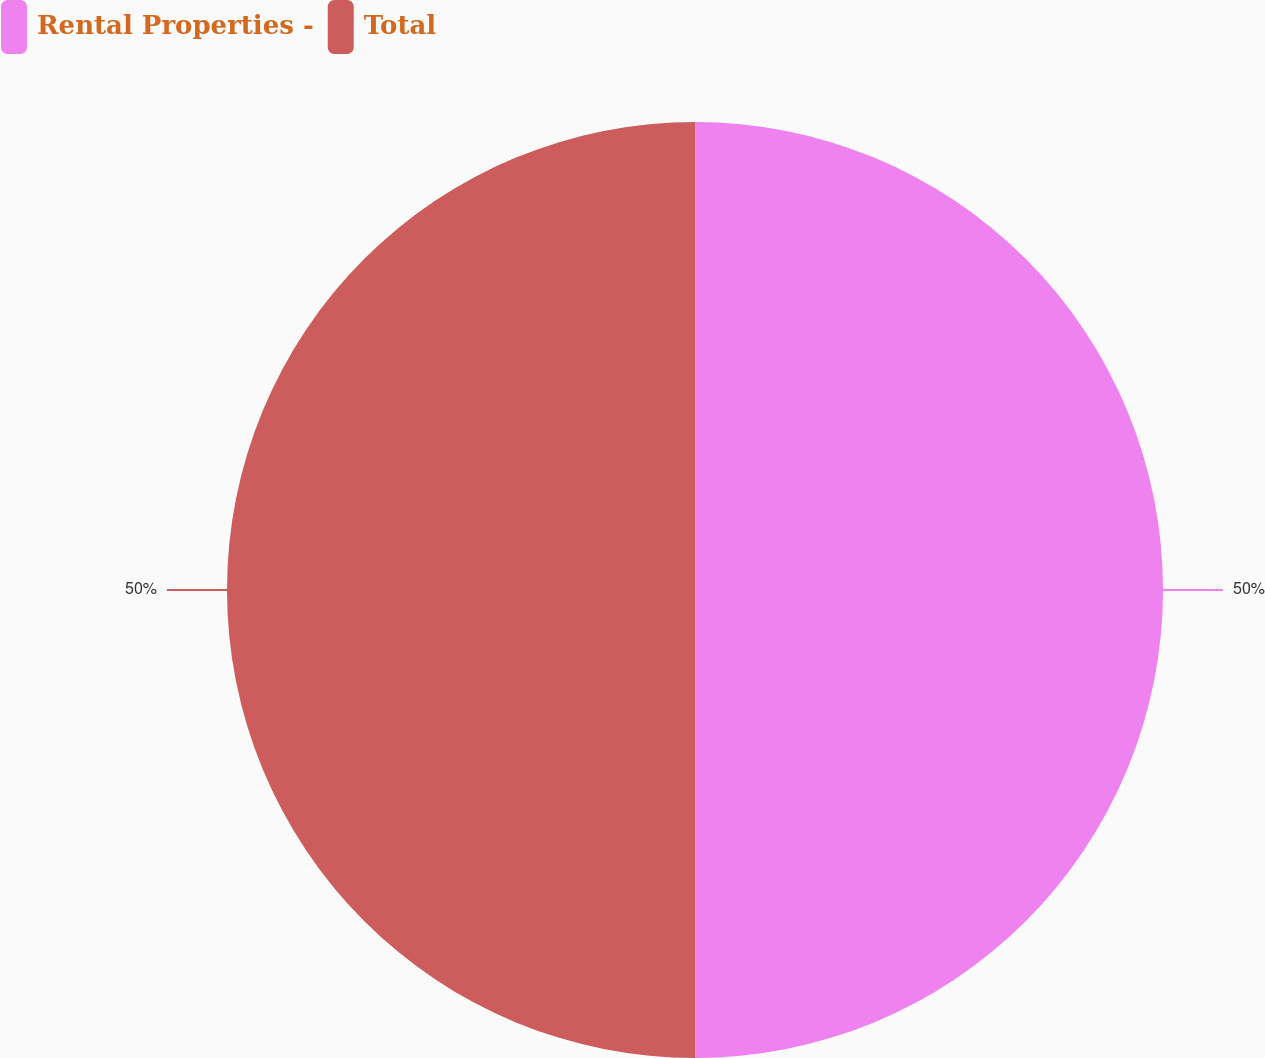<chart> <loc_0><loc_0><loc_500><loc_500><pie_chart><fcel>Rental Properties -<fcel>Total<nl><fcel>50.0%<fcel>50.0%<nl></chart> 